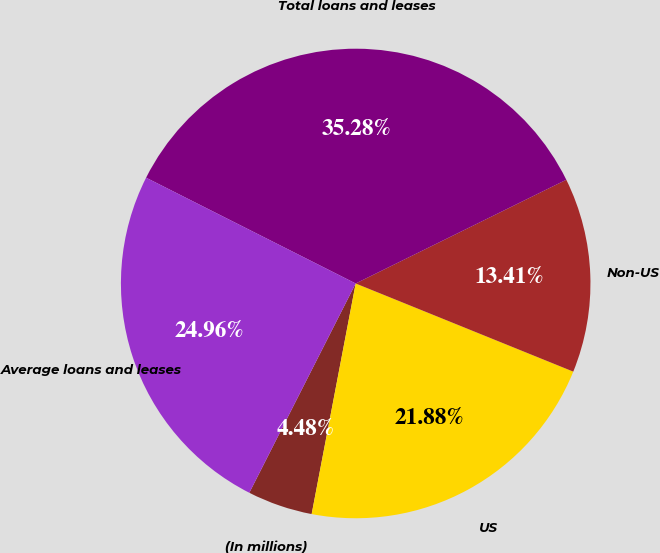<chart> <loc_0><loc_0><loc_500><loc_500><pie_chart><fcel>(In millions)<fcel>US<fcel>Non-US<fcel>Total loans and leases<fcel>Average loans and leases<nl><fcel>4.48%<fcel>21.88%<fcel>13.41%<fcel>35.28%<fcel>24.96%<nl></chart> 